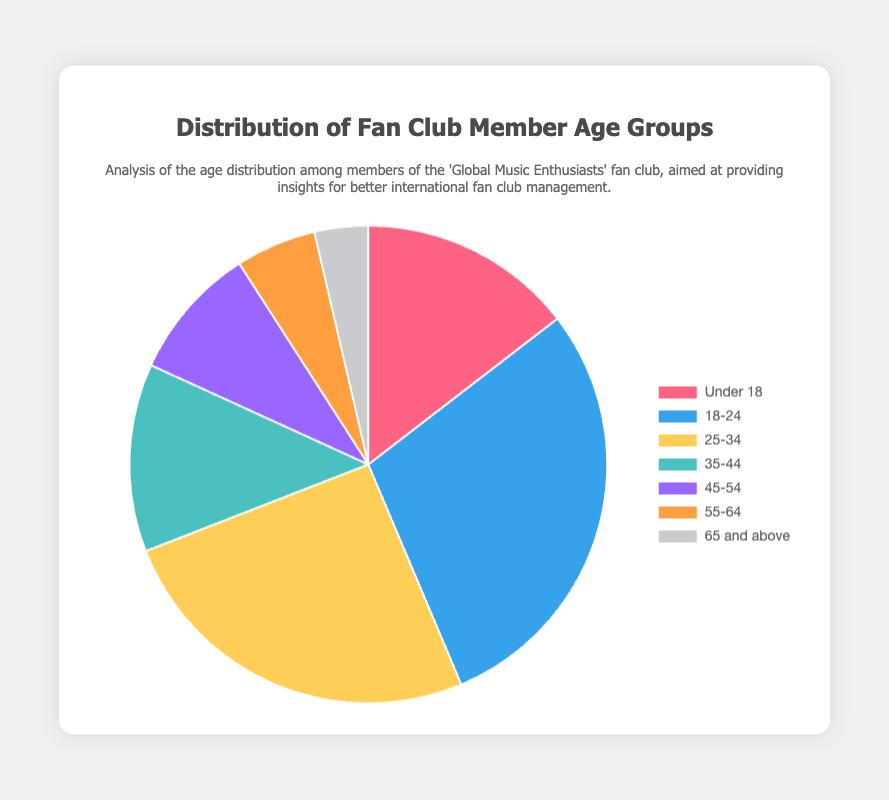What is the percentage of members aged 18-24? The data shows that there are 320 members in the 18-24 age group. The total number of members is 160 + 320 + 280 + 140 + 100 + 60 + 40 = 1100. The percentage is (320/1100) * 100 = 29.09%
Answer: 29.09% Which age group has the highest number of members? Among the provided data, the age group 18-24 has the highest member count of 320.
Answer: 18-24 What is the combined percentage of members aged under 18 and 25-34? The number of members in the Under 18 group is 160, and in the 25-34 group, it is 280. The total number of members is 1100. The combined member count for these groups is 160 + 280 = 440. The combined percentage is (440/1100) * 100 = 40%
Answer: 40% How does the number of members aged 35-44 compare to those aged 45-54? The member count for 35-44 is 140, while for 45-54 it is 100. The 35-44 age group has 40 more members than the 45-54 age group.
Answer: 40 more What is the smallest age group in terms of member count, and what percentage do they make up? The age group 65 and above has the smallest member count of 40. The percentage they make up is (40/1100) * 100 = 3.64%
Answer: 65 and above, 3.64% How many members are there in the age ranges 18-24 and 45-54 combined? The member count for the 18-24 age group is 320, and for the 45-54 age group, it is 100. Their combined count is 320 + 100 = 420.
Answer: 420 What is the difference in percentage points between the 55-64 and 65 and above age groups? The member count for the 55-64 age group is 60, and for the 65 and above group, it is 40. Their respective percentages are (60/1100) * 100 = 5.45% and (40/1100) * 100 = 3.64%. The difference is 5.45% - 3.64% = 1.81 percentage points.
Answer: 1.81 percentage points 